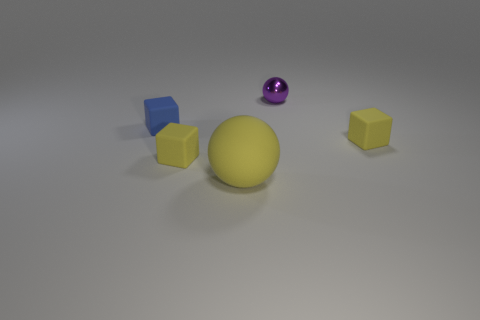Add 4 large objects. How many objects exist? 9 Subtract all spheres. How many objects are left? 3 Subtract 0 blue cylinders. How many objects are left? 5 Subtract all yellow metallic cylinders. Subtract all large rubber things. How many objects are left? 4 Add 4 yellow matte blocks. How many yellow matte blocks are left? 6 Add 5 tiny spheres. How many tiny spheres exist? 6 